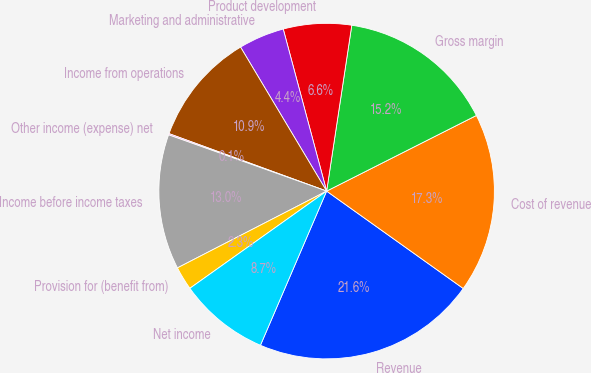Convert chart. <chart><loc_0><loc_0><loc_500><loc_500><pie_chart><fcel>Revenue<fcel>Cost of revenue<fcel>Gross margin<fcel>Product development<fcel>Marketing and administrative<fcel>Income from operations<fcel>Other income (expense) net<fcel>Income before income taxes<fcel>Provision for (benefit from)<fcel>Net income<nl><fcel>21.6%<fcel>17.3%<fcel>15.16%<fcel>6.56%<fcel>4.41%<fcel>10.86%<fcel>0.12%<fcel>13.01%<fcel>2.27%<fcel>8.71%<nl></chart> 